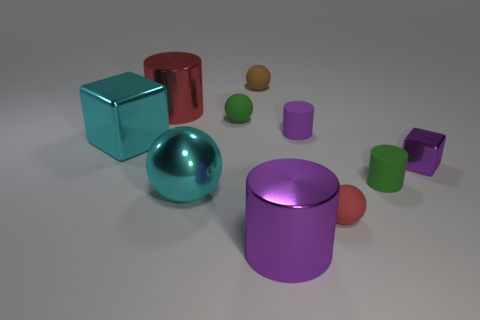How many other shiny objects have the same shape as the big purple thing?
Provide a short and direct response. 1. Is the number of big cyan metal objects that are in front of the red ball less than the number of tiny metallic cubes?
Give a very brief answer. Yes. What shape is the small red thing?
Your answer should be very brief. Sphere. How big is the red object that is behind the large cyan metal cube?
Keep it short and to the point. Large. What is the color of the metal block that is the same size as the cyan ball?
Keep it short and to the point. Cyan. Is there a small cylinder of the same color as the small metal cube?
Give a very brief answer. Yes. Are there fewer large cyan objects that are left of the big red thing than metal objects behind the large purple cylinder?
Provide a succinct answer. Yes. What material is the tiny object that is in front of the tiny purple metallic thing and right of the small red rubber sphere?
Keep it short and to the point. Rubber. There is a big purple metallic object; is its shape the same as the small green rubber thing to the left of the tiny red thing?
Offer a terse response. No. What number of other things are the same size as the purple block?
Give a very brief answer. 5. 